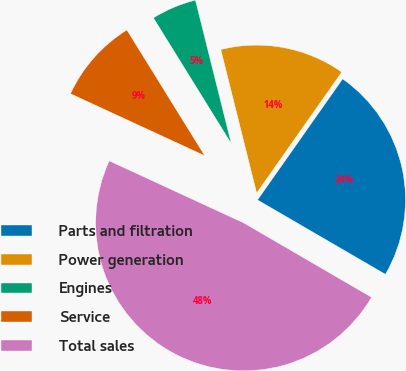Convert chart. <chart><loc_0><loc_0><loc_500><loc_500><pie_chart><fcel>Parts and filtration<fcel>Power generation<fcel>Engines<fcel>Service<fcel>Total sales<nl><fcel>23.63%<fcel>13.65%<fcel>4.93%<fcel>9.29%<fcel>48.5%<nl></chart> 